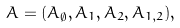<formula> <loc_0><loc_0><loc_500><loc_500>A = ( A _ { \emptyset } , A _ { 1 } , A _ { 2 } , A _ { 1 , 2 } ) ,</formula> 